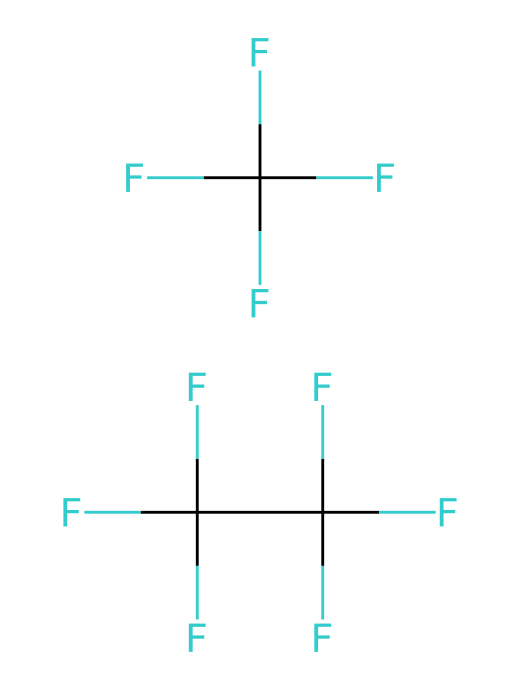What is the molecular formula for R-410A? By analyzing the given SMILES notation, we can identify that R-410A consists of various atoms. The two distinct parts in the SMILES indicate two separate molecules: each containing carbon (C), fluorine (F), and hydrogen (H). Counting and deducing the molecular formula results in C 1, H 0, and F 4, and since there are two parts in total, we write the formula as C 2 H 0 F 8.
Answer: C2H2F8 How many carbon atoms are present in R-410A? Looking at the structure represented by the SMILES, we can see that there are two carbon atoms present in the overall molecular structure. Each segment of the SMILES shows a carbon atom as part of the refrigerant blend.
Answer: 2 What type of chemical bonding is primarily found in R-410A? The chemical structure reveals that R-410A is composed mainly of carbon-fluorine bonds. Fluorine has a high electronegativity, resulting in strong covalent bonds with carbon, making these bonds a significant characteristic of the refrigerant's stability.
Answer: carbon-fluorine bonds What is the total number of fluorine atoms in R-410A? The SMILES representation indicates multiple fluorine atoms connected to the carbon atoms. By counting the 'F's in the full SMILES representation, we can confirm that there are a total of eight fluorine atoms in the molecule.
Answer: 8 Is R-410A considered to be environmentally friendly? The environmental classification of R-410A suggests that it has a reduced impact on ozone depletion compared to certain other refrigerants, but it is still a greenhouse gas with significant global warming potential. Therefore, while it is less harmful in some respects, it is not completely environmentally friendly.
Answer: No 